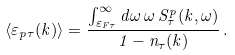<formula> <loc_0><loc_0><loc_500><loc_500>\langle \varepsilon _ { p \tau } ( k ) \rangle = \frac { \int ^ { \infty } _ { \varepsilon _ { F \tau } } d \omega \, \omega \, S ^ { p } _ { \tau } ( k , \omega ) } { 1 - n _ { \tau } ( k ) } \, .</formula> 